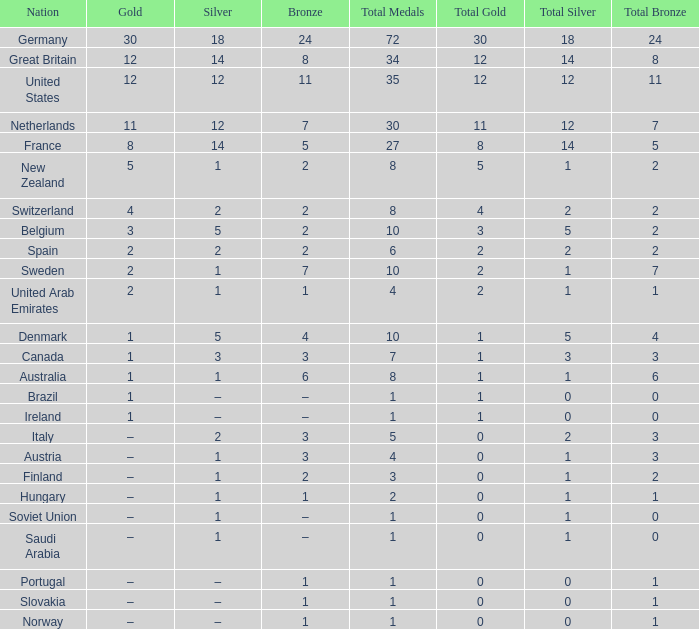If bronze is 11, what would gold be? 12.0. 